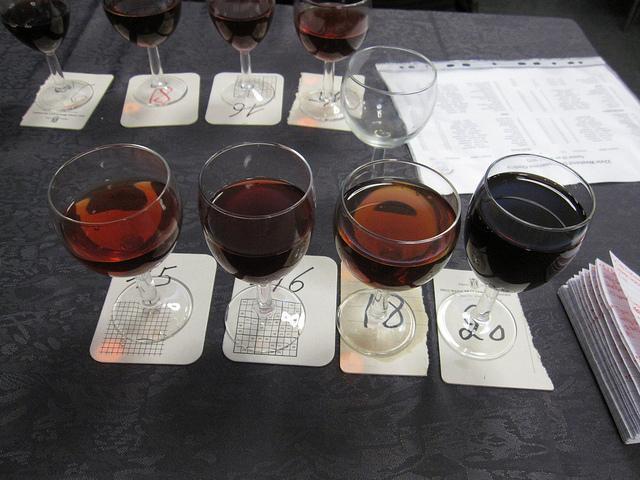What activity is the person taking this pic taking part in here?
Choose the correct response and explain in the format: 'Answer: answer
Rationale: rationale.'
Options: Glutton fest, tasting, drunken toot, binge. Answer: tasting.
Rationale: The primary items in the picture are glasses filled with wine.  the fact that each has a different color and a number marked under them leads one to believe that this is part of a contest or wine testing event. 